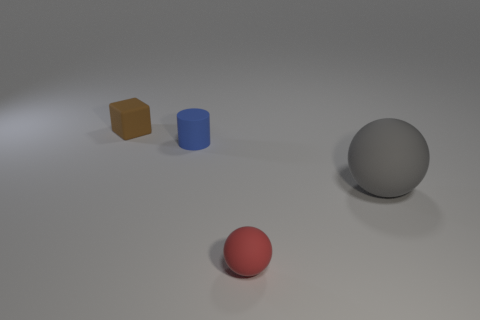Add 1 small blue rubber objects. How many objects exist? 5 Subtract all red cylinders. Subtract all red blocks. How many cylinders are left? 1 Subtract all cylinders. How many objects are left? 3 Subtract all large cyan shiny cylinders. Subtract all tiny red objects. How many objects are left? 3 Add 4 brown blocks. How many brown blocks are left? 5 Add 4 small red balls. How many small red balls exist? 5 Subtract 0 cyan blocks. How many objects are left? 4 